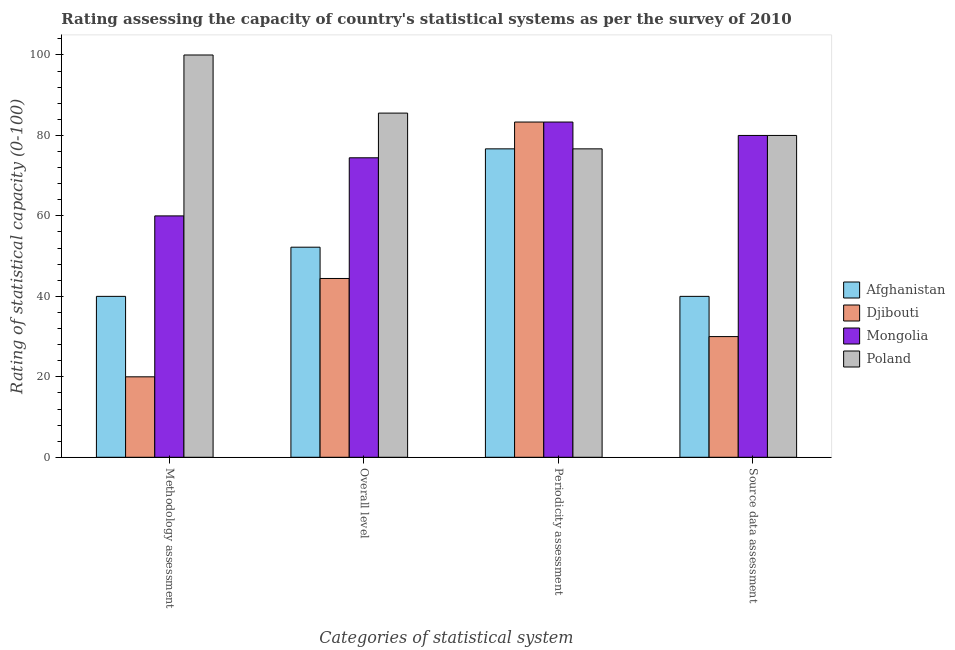How many different coloured bars are there?
Give a very brief answer. 4. Are the number of bars per tick equal to the number of legend labels?
Offer a terse response. Yes. Are the number of bars on each tick of the X-axis equal?
Offer a terse response. Yes. How many bars are there on the 2nd tick from the left?
Give a very brief answer. 4. What is the label of the 2nd group of bars from the left?
Your answer should be compact. Overall level. What is the methodology assessment rating in Afghanistan?
Your answer should be compact. 40. Across all countries, what is the maximum overall level rating?
Offer a terse response. 85.56. In which country was the periodicity assessment rating maximum?
Your response must be concise. Djibouti. In which country was the periodicity assessment rating minimum?
Your response must be concise. Afghanistan. What is the total methodology assessment rating in the graph?
Offer a very short reply. 220. What is the difference between the methodology assessment rating in Afghanistan and that in Poland?
Ensure brevity in your answer.  -60. What is the difference between the source data assessment rating in Djibouti and the overall level rating in Poland?
Give a very brief answer. -55.56. What is the average overall level rating per country?
Offer a very short reply. 64.17. What is the difference between the methodology assessment rating and overall level rating in Afghanistan?
Provide a succinct answer. -12.22. Is the difference between the source data assessment rating in Poland and Afghanistan greater than the difference between the overall level rating in Poland and Afghanistan?
Ensure brevity in your answer.  Yes. What is the difference between the highest and the second highest methodology assessment rating?
Provide a succinct answer. 40. What is the difference between the highest and the lowest periodicity assessment rating?
Provide a succinct answer. 6.67. Is it the case that in every country, the sum of the source data assessment rating and methodology assessment rating is greater than the sum of overall level rating and periodicity assessment rating?
Ensure brevity in your answer.  No. What does the 3rd bar from the left in Periodicity assessment represents?
Give a very brief answer. Mongolia. What does the 3rd bar from the right in Periodicity assessment represents?
Your answer should be compact. Djibouti. Is it the case that in every country, the sum of the methodology assessment rating and overall level rating is greater than the periodicity assessment rating?
Keep it short and to the point. No. Are all the bars in the graph horizontal?
Provide a short and direct response. No. How many countries are there in the graph?
Your answer should be compact. 4. What is the difference between two consecutive major ticks on the Y-axis?
Ensure brevity in your answer.  20. Does the graph contain grids?
Provide a succinct answer. No. What is the title of the graph?
Your response must be concise. Rating assessing the capacity of country's statistical systems as per the survey of 2010 . What is the label or title of the X-axis?
Offer a very short reply. Categories of statistical system. What is the label or title of the Y-axis?
Ensure brevity in your answer.  Rating of statistical capacity (0-100). What is the Rating of statistical capacity (0-100) in Mongolia in Methodology assessment?
Keep it short and to the point. 60. What is the Rating of statistical capacity (0-100) in Poland in Methodology assessment?
Provide a short and direct response. 100. What is the Rating of statistical capacity (0-100) of Afghanistan in Overall level?
Offer a very short reply. 52.22. What is the Rating of statistical capacity (0-100) of Djibouti in Overall level?
Provide a succinct answer. 44.44. What is the Rating of statistical capacity (0-100) in Mongolia in Overall level?
Keep it short and to the point. 74.44. What is the Rating of statistical capacity (0-100) in Poland in Overall level?
Your response must be concise. 85.56. What is the Rating of statistical capacity (0-100) of Afghanistan in Periodicity assessment?
Your answer should be compact. 76.67. What is the Rating of statistical capacity (0-100) of Djibouti in Periodicity assessment?
Offer a very short reply. 83.33. What is the Rating of statistical capacity (0-100) in Mongolia in Periodicity assessment?
Keep it short and to the point. 83.33. What is the Rating of statistical capacity (0-100) in Poland in Periodicity assessment?
Your answer should be compact. 76.67. What is the Rating of statistical capacity (0-100) of Mongolia in Source data assessment?
Give a very brief answer. 80. What is the Rating of statistical capacity (0-100) in Poland in Source data assessment?
Provide a succinct answer. 80. Across all Categories of statistical system, what is the maximum Rating of statistical capacity (0-100) in Afghanistan?
Keep it short and to the point. 76.67. Across all Categories of statistical system, what is the maximum Rating of statistical capacity (0-100) of Djibouti?
Your answer should be compact. 83.33. Across all Categories of statistical system, what is the maximum Rating of statistical capacity (0-100) of Mongolia?
Your response must be concise. 83.33. Across all Categories of statistical system, what is the maximum Rating of statistical capacity (0-100) in Poland?
Offer a very short reply. 100. Across all Categories of statistical system, what is the minimum Rating of statistical capacity (0-100) of Afghanistan?
Your response must be concise. 40. Across all Categories of statistical system, what is the minimum Rating of statistical capacity (0-100) in Poland?
Your answer should be compact. 76.67. What is the total Rating of statistical capacity (0-100) of Afghanistan in the graph?
Provide a succinct answer. 208.89. What is the total Rating of statistical capacity (0-100) in Djibouti in the graph?
Provide a short and direct response. 177.78. What is the total Rating of statistical capacity (0-100) of Mongolia in the graph?
Provide a succinct answer. 297.78. What is the total Rating of statistical capacity (0-100) in Poland in the graph?
Offer a very short reply. 342.22. What is the difference between the Rating of statistical capacity (0-100) of Afghanistan in Methodology assessment and that in Overall level?
Offer a terse response. -12.22. What is the difference between the Rating of statistical capacity (0-100) in Djibouti in Methodology assessment and that in Overall level?
Provide a short and direct response. -24.44. What is the difference between the Rating of statistical capacity (0-100) in Mongolia in Methodology assessment and that in Overall level?
Provide a succinct answer. -14.44. What is the difference between the Rating of statistical capacity (0-100) in Poland in Methodology assessment and that in Overall level?
Offer a terse response. 14.44. What is the difference between the Rating of statistical capacity (0-100) in Afghanistan in Methodology assessment and that in Periodicity assessment?
Offer a very short reply. -36.67. What is the difference between the Rating of statistical capacity (0-100) in Djibouti in Methodology assessment and that in Periodicity assessment?
Offer a terse response. -63.33. What is the difference between the Rating of statistical capacity (0-100) of Mongolia in Methodology assessment and that in Periodicity assessment?
Offer a terse response. -23.33. What is the difference between the Rating of statistical capacity (0-100) in Poland in Methodology assessment and that in Periodicity assessment?
Ensure brevity in your answer.  23.33. What is the difference between the Rating of statistical capacity (0-100) in Mongolia in Methodology assessment and that in Source data assessment?
Keep it short and to the point. -20. What is the difference between the Rating of statistical capacity (0-100) in Afghanistan in Overall level and that in Periodicity assessment?
Provide a succinct answer. -24.44. What is the difference between the Rating of statistical capacity (0-100) of Djibouti in Overall level and that in Periodicity assessment?
Offer a very short reply. -38.89. What is the difference between the Rating of statistical capacity (0-100) in Mongolia in Overall level and that in Periodicity assessment?
Provide a short and direct response. -8.89. What is the difference between the Rating of statistical capacity (0-100) in Poland in Overall level and that in Periodicity assessment?
Keep it short and to the point. 8.89. What is the difference between the Rating of statistical capacity (0-100) in Afghanistan in Overall level and that in Source data assessment?
Offer a very short reply. 12.22. What is the difference between the Rating of statistical capacity (0-100) in Djibouti in Overall level and that in Source data assessment?
Ensure brevity in your answer.  14.44. What is the difference between the Rating of statistical capacity (0-100) in Mongolia in Overall level and that in Source data assessment?
Ensure brevity in your answer.  -5.56. What is the difference between the Rating of statistical capacity (0-100) in Poland in Overall level and that in Source data assessment?
Give a very brief answer. 5.56. What is the difference between the Rating of statistical capacity (0-100) in Afghanistan in Periodicity assessment and that in Source data assessment?
Provide a short and direct response. 36.67. What is the difference between the Rating of statistical capacity (0-100) of Djibouti in Periodicity assessment and that in Source data assessment?
Offer a very short reply. 53.33. What is the difference between the Rating of statistical capacity (0-100) in Poland in Periodicity assessment and that in Source data assessment?
Make the answer very short. -3.33. What is the difference between the Rating of statistical capacity (0-100) in Afghanistan in Methodology assessment and the Rating of statistical capacity (0-100) in Djibouti in Overall level?
Your answer should be very brief. -4.44. What is the difference between the Rating of statistical capacity (0-100) in Afghanistan in Methodology assessment and the Rating of statistical capacity (0-100) in Mongolia in Overall level?
Provide a short and direct response. -34.44. What is the difference between the Rating of statistical capacity (0-100) in Afghanistan in Methodology assessment and the Rating of statistical capacity (0-100) in Poland in Overall level?
Provide a short and direct response. -45.56. What is the difference between the Rating of statistical capacity (0-100) of Djibouti in Methodology assessment and the Rating of statistical capacity (0-100) of Mongolia in Overall level?
Your response must be concise. -54.44. What is the difference between the Rating of statistical capacity (0-100) of Djibouti in Methodology assessment and the Rating of statistical capacity (0-100) of Poland in Overall level?
Offer a terse response. -65.56. What is the difference between the Rating of statistical capacity (0-100) in Mongolia in Methodology assessment and the Rating of statistical capacity (0-100) in Poland in Overall level?
Keep it short and to the point. -25.56. What is the difference between the Rating of statistical capacity (0-100) in Afghanistan in Methodology assessment and the Rating of statistical capacity (0-100) in Djibouti in Periodicity assessment?
Your response must be concise. -43.33. What is the difference between the Rating of statistical capacity (0-100) in Afghanistan in Methodology assessment and the Rating of statistical capacity (0-100) in Mongolia in Periodicity assessment?
Offer a terse response. -43.33. What is the difference between the Rating of statistical capacity (0-100) of Afghanistan in Methodology assessment and the Rating of statistical capacity (0-100) of Poland in Periodicity assessment?
Provide a succinct answer. -36.67. What is the difference between the Rating of statistical capacity (0-100) in Djibouti in Methodology assessment and the Rating of statistical capacity (0-100) in Mongolia in Periodicity assessment?
Your response must be concise. -63.33. What is the difference between the Rating of statistical capacity (0-100) in Djibouti in Methodology assessment and the Rating of statistical capacity (0-100) in Poland in Periodicity assessment?
Provide a short and direct response. -56.67. What is the difference between the Rating of statistical capacity (0-100) of Mongolia in Methodology assessment and the Rating of statistical capacity (0-100) of Poland in Periodicity assessment?
Give a very brief answer. -16.67. What is the difference between the Rating of statistical capacity (0-100) in Afghanistan in Methodology assessment and the Rating of statistical capacity (0-100) in Mongolia in Source data assessment?
Provide a short and direct response. -40. What is the difference between the Rating of statistical capacity (0-100) of Afghanistan in Methodology assessment and the Rating of statistical capacity (0-100) of Poland in Source data assessment?
Your response must be concise. -40. What is the difference between the Rating of statistical capacity (0-100) of Djibouti in Methodology assessment and the Rating of statistical capacity (0-100) of Mongolia in Source data assessment?
Your response must be concise. -60. What is the difference between the Rating of statistical capacity (0-100) of Djibouti in Methodology assessment and the Rating of statistical capacity (0-100) of Poland in Source data assessment?
Offer a terse response. -60. What is the difference between the Rating of statistical capacity (0-100) in Afghanistan in Overall level and the Rating of statistical capacity (0-100) in Djibouti in Periodicity assessment?
Your answer should be very brief. -31.11. What is the difference between the Rating of statistical capacity (0-100) in Afghanistan in Overall level and the Rating of statistical capacity (0-100) in Mongolia in Periodicity assessment?
Provide a short and direct response. -31.11. What is the difference between the Rating of statistical capacity (0-100) of Afghanistan in Overall level and the Rating of statistical capacity (0-100) of Poland in Periodicity assessment?
Give a very brief answer. -24.44. What is the difference between the Rating of statistical capacity (0-100) of Djibouti in Overall level and the Rating of statistical capacity (0-100) of Mongolia in Periodicity assessment?
Provide a succinct answer. -38.89. What is the difference between the Rating of statistical capacity (0-100) of Djibouti in Overall level and the Rating of statistical capacity (0-100) of Poland in Periodicity assessment?
Make the answer very short. -32.22. What is the difference between the Rating of statistical capacity (0-100) of Mongolia in Overall level and the Rating of statistical capacity (0-100) of Poland in Periodicity assessment?
Provide a short and direct response. -2.22. What is the difference between the Rating of statistical capacity (0-100) in Afghanistan in Overall level and the Rating of statistical capacity (0-100) in Djibouti in Source data assessment?
Your response must be concise. 22.22. What is the difference between the Rating of statistical capacity (0-100) in Afghanistan in Overall level and the Rating of statistical capacity (0-100) in Mongolia in Source data assessment?
Ensure brevity in your answer.  -27.78. What is the difference between the Rating of statistical capacity (0-100) of Afghanistan in Overall level and the Rating of statistical capacity (0-100) of Poland in Source data assessment?
Ensure brevity in your answer.  -27.78. What is the difference between the Rating of statistical capacity (0-100) in Djibouti in Overall level and the Rating of statistical capacity (0-100) in Mongolia in Source data assessment?
Ensure brevity in your answer.  -35.56. What is the difference between the Rating of statistical capacity (0-100) of Djibouti in Overall level and the Rating of statistical capacity (0-100) of Poland in Source data assessment?
Provide a short and direct response. -35.56. What is the difference between the Rating of statistical capacity (0-100) of Mongolia in Overall level and the Rating of statistical capacity (0-100) of Poland in Source data assessment?
Offer a terse response. -5.56. What is the difference between the Rating of statistical capacity (0-100) of Afghanistan in Periodicity assessment and the Rating of statistical capacity (0-100) of Djibouti in Source data assessment?
Provide a succinct answer. 46.67. What is the difference between the Rating of statistical capacity (0-100) of Afghanistan in Periodicity assessment and the Rating of statistical capacity (0-100) of Poland in Source data assessment?
Give a very brief answer. -3.33. What is the difference between the Rating of statistical capacity (0-100) in Djibouti in Periodicity assessment and the Rating of statistical capacity (0-100) in Poland in Source data assessment?
Provide a short and direct response. 3.33. What is the difference between the Rating of statistical capacity (0-100) of Mongolia in Periodicity assessment and the Rating of statistical capacity (0-100) of Poland in Source data assessment?
Your answer should be very brief. 3.33. What is the average Rating of statistical capacity (0-100) of Afghanistan per Categories of statistical system?
Your answer should be very brief. 52.22. What is the average Rating of statistical capacity (0-100) of Djibouti per Categories of statistical system?
Keep it short and to the point. 44.44. What is the average Rating of statistical capacity (0-100) of Mongolia per Categories of statistical system?
Provide a succinct answer. 74.44. What is the average Rating of statistical capacity (0-100) in Poland per Categories of statistical system?
Your response must be concise. 85.56. What is the difference between the Rating of statistical capacity (0-100) of Afghanistan and Rating of statistical capacity (0-100) of Poland in Methodology assessment?
Provide a short and direct response. -60. What is the difference between the Rating of statistical capacity (0-100) in Djibouti and Rating of statistical capacity (0-100) in Poland in Methodology assessment?
Provide a succinct answer. -80. What is the difference between the Rating of statistical capacity (0-100) of Afghanistan and Rating of statistical capacity (0-100) of Djibouti in Overall level?
Your answer should be compact. 7.78. What is the difference between the Rating of statistical capacity (0-100) in Afghanistan and Rating of statistical capacity (0-100) in Mongolia in Overall level?
Make the answer very short. -22.22. What is the difference between the Rating of statistical capacity (0-100) of Afghanistan and Rating of statistical capacity (0-100) of Poland in Overall level?
Your response must be concise. -33.33. What is the difference between the Rating of statistical capacity (0-100) of Djibouti and Rating of statistical capacity (0-100) of Mongolia in Overall level?
Provide a succinct answer. -30. What is the difference between the Rating of statistical capacity (0-100) in Djibouti and Rating of statistical capacity (0-100) in Poland in Overall level?
Ensure brevity in your answer.  -41.11. What is the difference between the Rating of statistical capacity (0-100) of Mongolia and Rating of statistical capacity (0-100) of Poland in Overall level?
Give a very brief answer. -11.11. What is the difference between the Rating of statistical capacity (0-100) in Afghanistan and Rating of statistical capacity (0-100) in Djibouti in Periodicity assessment?
Provide a short and direct response. -6.67. What is the difference between the Rating of statistical capacity (0-100) in Afghanistan and Rating of statistical capacity (0-100) in Mongolia in Periodicity assessment?
Give a very brief answer. -6.67. What is the difference between the Rating of statistical capacity (0-100) in Djibouti and Rating of statistical capacity (0-100) in Poland in Periodicity assessment?
Offer a very short reply. 6.67. What is the difference between the Rating of statistical capacity (0-100) of Djibouti and Rating of statistical capacity (0-100) of Mongolia in Source data assessment?
Your answer should be very brief. -50. What is the ratio of the Rating of statistical capacity (0-100) in Afghanistan in Methodology assessment to that in Overall level?
Your response must be concise. 0.77. What is the ratio of the Rating of statistical capacity (0-100) of Djibouti in Methodology assessment to that in Overall level?
Keep it short and to the point. 0.45. What is the ratio of the Rating of statistical capacity (0-100) in Mongolia in Methodology assessment to that in Overall level?
Your response must be concise. 0.81. What is the ratio of the Rating of statistical capacity (0-100) of Poland in Methodology assessment to that in Overall level?
Offer a terse response. 1.17. What is the ratio of the Rating of statistical capacity (0-100) of Afghanistan in Methodology assessment to that in Periodicity assessment?
Provide a short and direct response. 0.52. What is the ratio of the Rating of statistical capacity (0-100) of Djibouti in Methodology assessment to that in Periodicity assessment?
Your answer should be compact. 0.24. What is the ratio of the Rating of statistical capacity (0-100) of Mongolia in Methodology assessment to that in Periodicity assessment?
Keep it short and to the point. 0.72. What is the ratio of the Rating of statistical capacity (0-100) in Poland in Methodology assessment to that in Periodicity assessment?
Your answer should be compact. 1.3. What is the ratio of the Rating of statistical capacity (0-100) in Mongolia in Methodology assessment to that in Source data assessment?
Keep it short and to the point. 0.75. What is the ratio of the Rating of statistical capacity (0-100) of Poland in Methodology assessment to that in Source data assessment?
Offer a terse response. 1.25. What is the ratio of the Rating of statistical capacity (0-100) of Afghanistan in Overall level to that in Periodicity assessment?
Provide a succinct answer. 0.68. What is the ratio of the Rating of statistical capacity (0-100) in Djibouti in Overall level to that in Periodicity assessment?
Ensure brevity in your answer.  0.53. What is the ratio of the Rating of statistical capacity (0-100) in Mongolia in Overall level to that in Periodicity assessment?
Offer a very short reply. 0.89. What is the ratio of the Rating of statistical capacity (0-100) in Poland in Overall level to that in Periodicity assessment?
Provide a succinct answer. 1.12. What is the ratio of the Rating of statistical capacity (0-100) of Afghanistan in Overall level to that in Source data assessment?
Provide a short and direct response. 1.31. What is the ratio of the Rating of statistical capacity (0-100) of Djibouti in Overall level to that in Source data assessment?
Give a very brief answer. 1.48. What is the ratio of the Rating of statistical capacity (0-100) in Mongolia in Overall level to that in Source data assessment?
Provide a short and direct response. 0.93. What is the ratio of the Rating of statistical capacity (0-100) in Poland in Overall level to that in Source data assessment?
Provide a succinct answer. 1.07. What is the ratio of the Rating of statistical capacity (0-100) of Afghanistan in Periodicity assessment to that in Source data assessment?
Your answer should be compact. 1.92. What is the ratio of the Rating of statistical capacity (0-100) of Djibouti in Periodicity assessment to that in Source data assessment?
Your answer should be compact. 2.78. What is the ratio of the Rating of statistical capacity (0-100) of Mongolia in Periodicity assessment to that in Source data assessment?
Keep it short and to the point. 1.04. What is the difference between the highest and the second highest Rating of statistical capacity (0-100) of Afghanistan?
Offer a terse response. 24.44. What is the difference between the highest and the second highest Rating of statistical capacity (0-100) in Djibouti?
Give a very brief answer. 38.89. What is the difference between the highest and the second highest Rating of statistical capacity (0-100) of Mongolia?
Your response must be concise. 3.33. What is the difference between the highest and the second highest Rating of statistical capacity (0-100) in Poland?
Give a very brief answer. 14.44. What is the difference between the highest and the lowest Rating of statistical capacity (0-100) in Afghanistan?
Your response must be concise. 36.67. What is the difference between the highest and the lowest Rating of statistical capacity (0-100) of Djibouti?
Offer a very short reply. 63.33. What is the difference between the highest and the lowest Rating of statistical capacity (0-100) of Mongolia?
Offer a terse response. 23.33. What is the difference between the highest and the lowest Rating of statistical capacity (0-100) of Poland?
Your answer should be very brief. 23.33. 